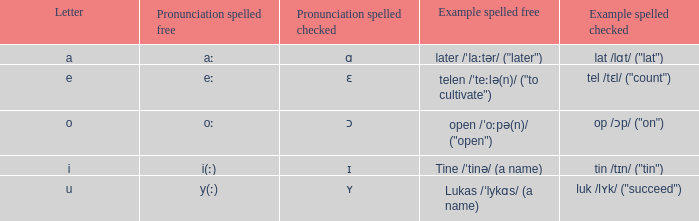What is Pronunciation Spelled Checked, when Example Spelled Checked is "tin /tɪn/ ("tin")" Ɪ. 